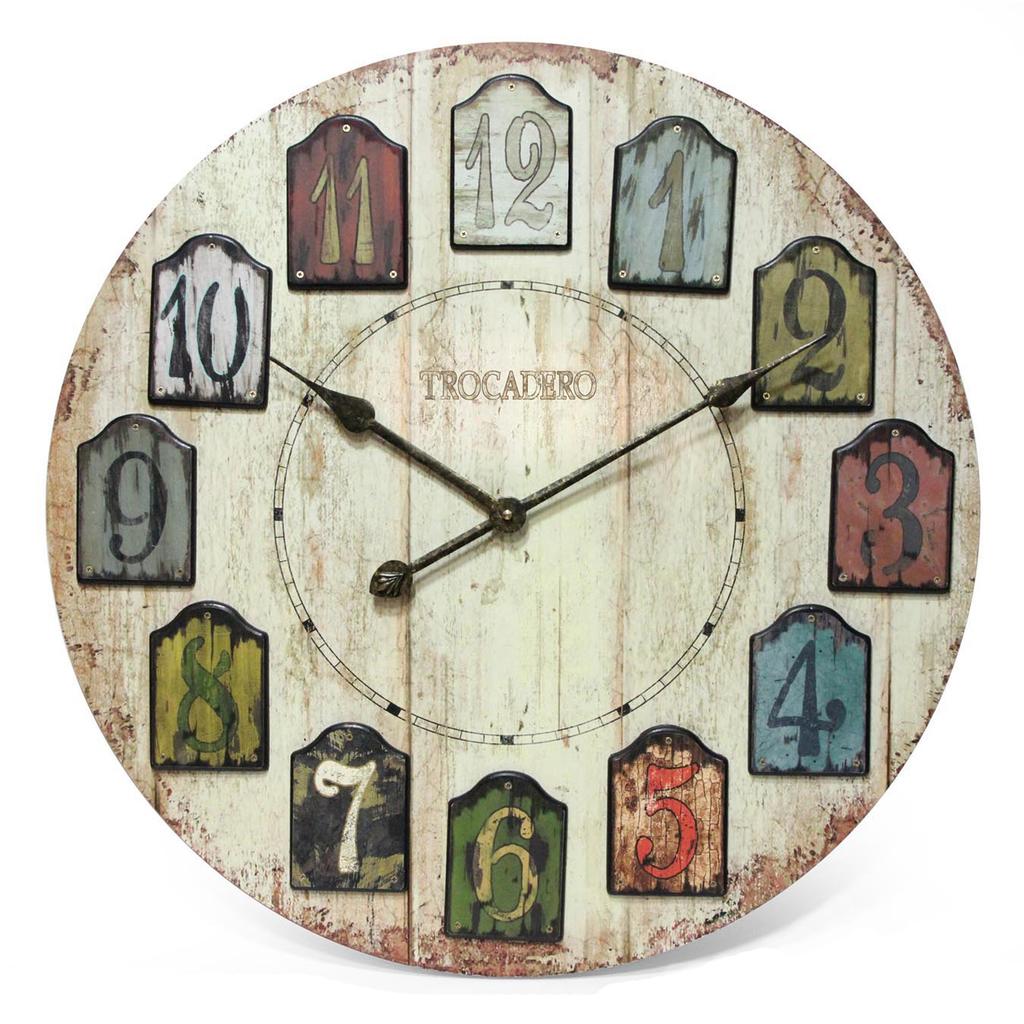What time is it on the clock?
Keep it short and to the point. 10:10. What is the name on the clock?
Give a very brief answer. Trocadero. 